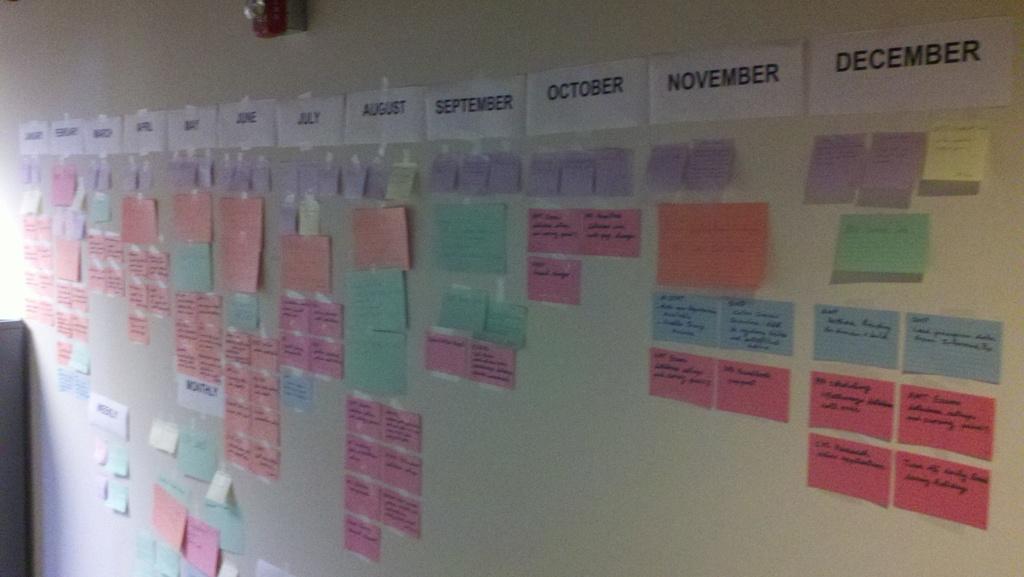Which month shown has the fewest number of letters?
Provide a succinct answer. October. 